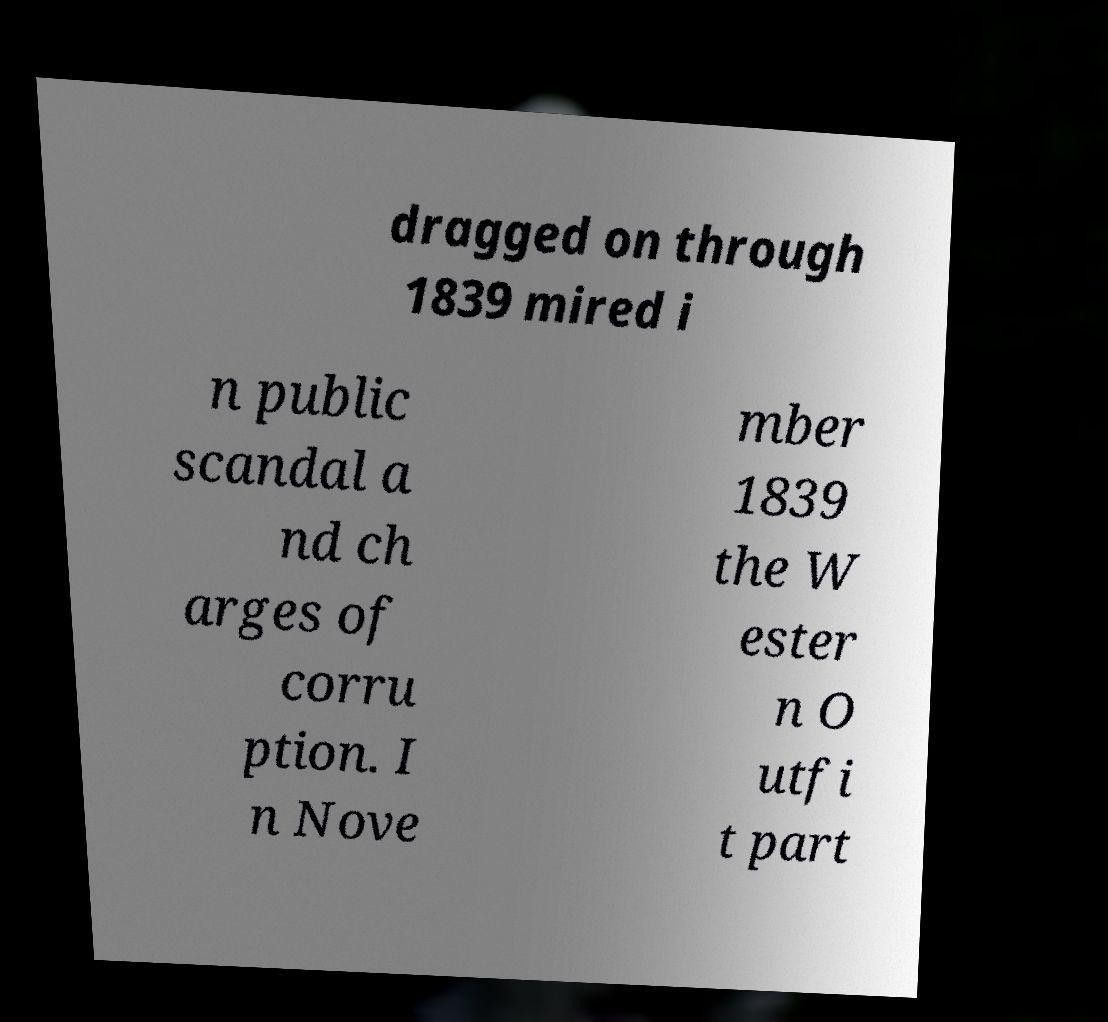I need the written content from this picture converted into text. Can you do that? dragged on through 1839 mired i n public scandal a nd ch arges of corru ption. I n Nove mber 1839 the W ester n O utfi t part 